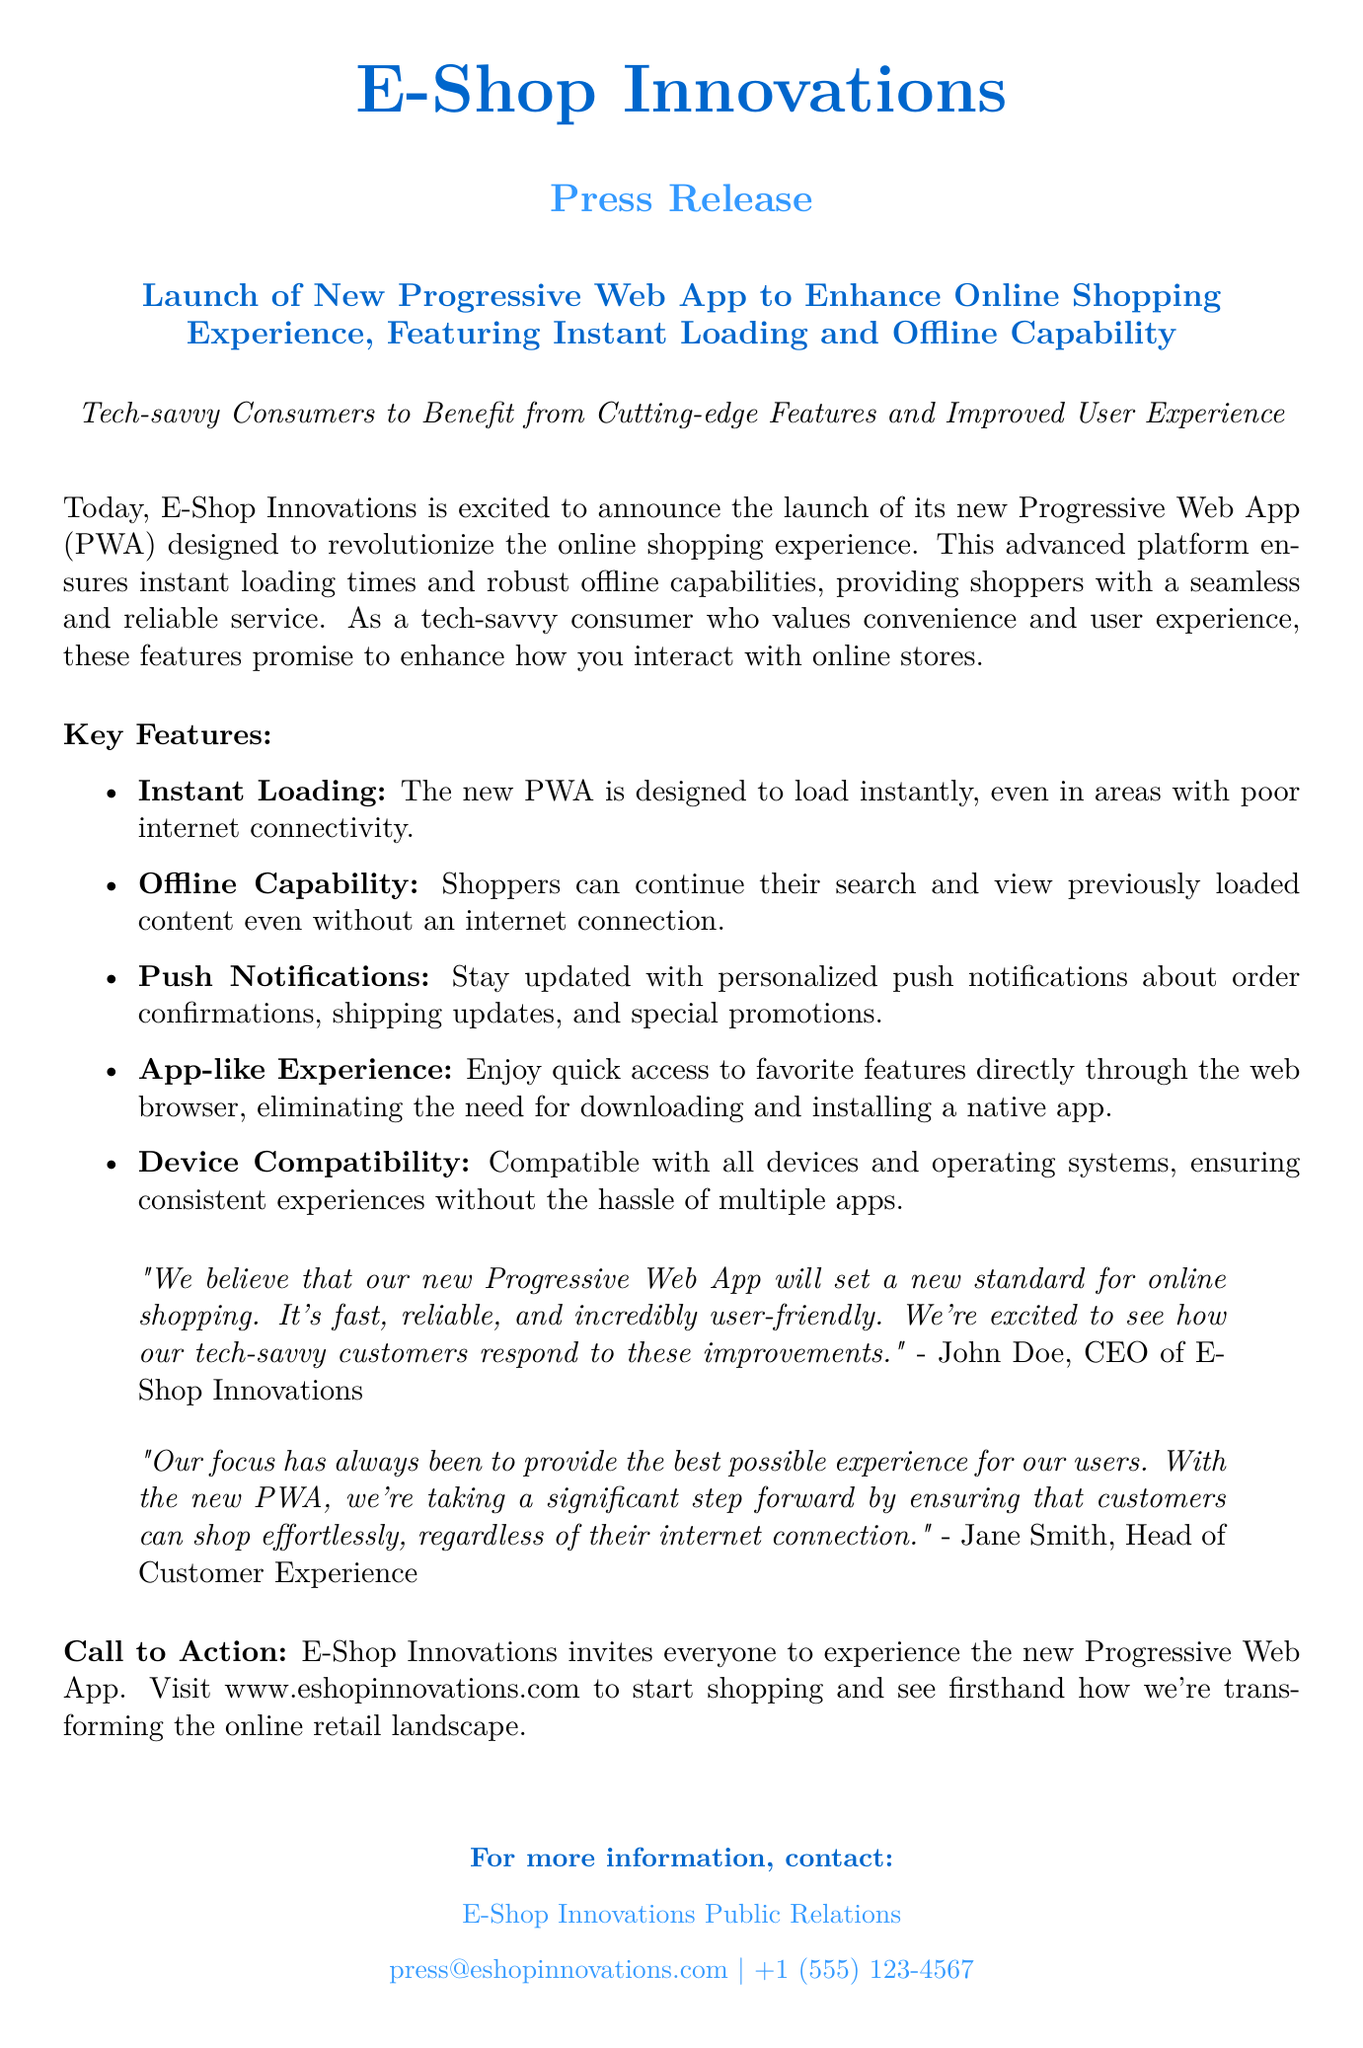What is the name of the company launching the new PWA? The document states that E-Shop Innovations is launching the new PWA.
Answer: E-Shop Innovations What is the main purpose of the new Progressive Web App? The purpose of the new PWA is to enhance the online shopping experience for consumers.
Answer: Enhance online shopping experience What are the two key features emphasized in the press release? The features highlighted are instant loading and offline capability for the PWA.
Answer: Instant loading and offline capability Who is the CEO of E-Shop Innovations? The CEO is mentioned in the document as John Doe.
Answer: John Doe What type of notifications will the new PWA provide to users? The PWA provides personalized push notifications about order confirmations, shipping updates, and promotions.
Answer: Push notifications How does the new PWA ensure an app-like experience for users? It allows quick access to favorite features directly through the web browser without needing to install a native app.
Answer: App-like experience What is the website address mentioned for experiencing the new PWA? The document invites users to visit www.eshopinnovations.com to experience the new PWA.
Answer: www.eshopinnovations.com What is the contact email provided for Public Relations? The email for E-Shop Innovations Public Relations is given in the document.
Answer: press@eshopinnovations.com What statement emphasizes the intended benefits for tech-savvy consumers? The CEO mentions excitement about how tech-savvy customers will respond to the improvements made.
Answer: Respond to these improvements 